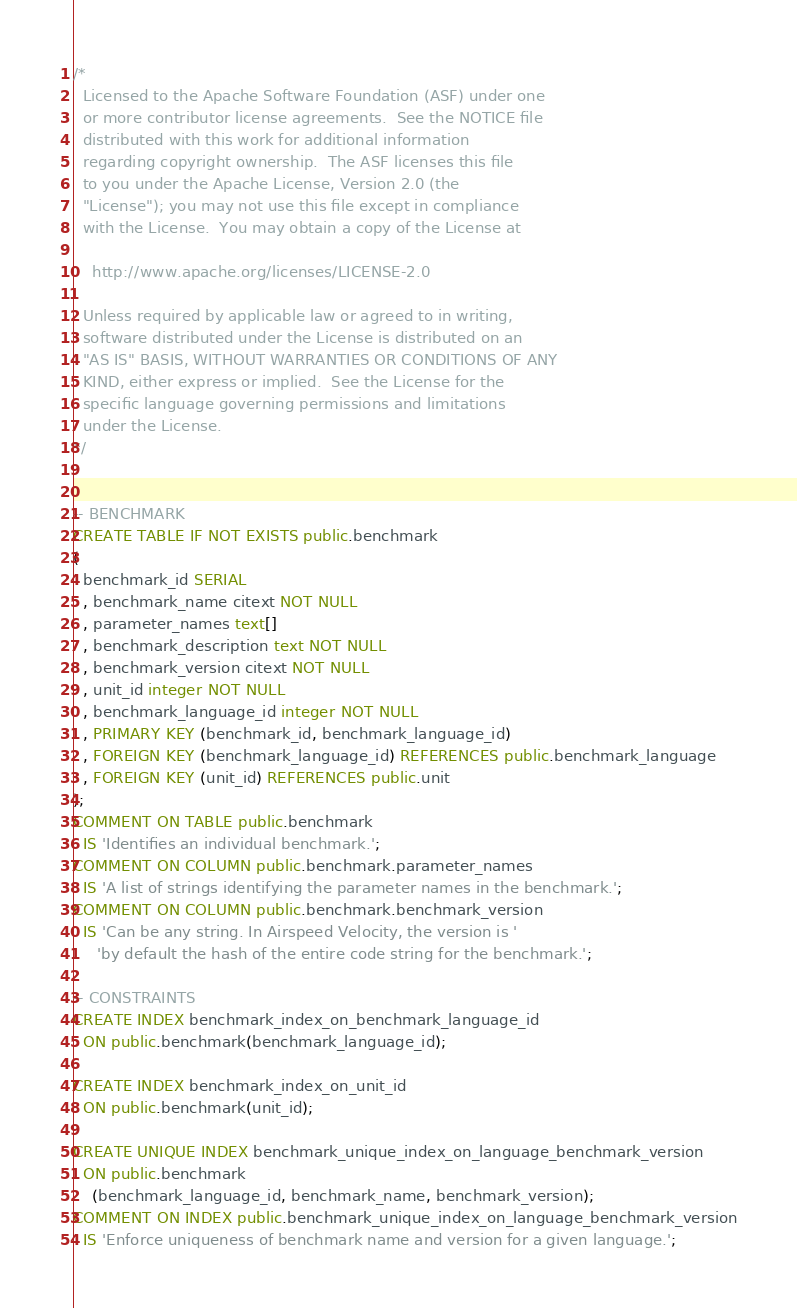<code> <loc_0><loc_0><loc_500><loc_500><_SQL_>/*
  Licensed to the Apache Software Foundation (ASF) under one
  or more contributor license agreements.  See the NOTICE file
  distributed with this work for additional information
  regarding copyright ownership.  The ASF licenses this file
  to you under the Apache License, Version 2.0 (the
  "License"); you may not use this file except in compliance
  with the License.  You may obtain a copy of the License at

    http://www.apache.org/licenses/LICENSE-2.0

  Unless required by applicable law or agreed to in writing,
  software distributed under the License is distributed on an
  "AS IS" BASIS, WITHOUT WARRANTIES OR CONDITIONS OF ANY
  KIND, either express or implied.  See the License for the
  specific language governing permissions and limitations
  under the License.
*/


-- BENCHMARK
CREATE TABLE IF NOT EXISTS public.benchmark
(
  benchmark_id SERIAL
  , benchmark_name citext NOT NULL
  , parameter_names text[]
  , benchmark_description text NOT NULL
  , benchmark_version citext NOT NULL
  , unit_id integer NOT NULL
  , benchmark_language_id integer NOT NULL
  , PRIMARY KEY (benchmark_id, benchmark_language_id)
  , FOREIGN KEY (benchmark_language_id) REFERENCES public.benchmark_language
  , FOREIGN KEY (unit_id) REFERENCES public.unit
);
COMMENT ON TABLE public.benchmark
  IS 'Identifies an individual benchmark.';
COMMENT ON COLUMN public.benchmark.parameter_names
  IS 'A list of strings identifying the parameter names in the benchmark.';
COMMENT ON COLUMN public.benchmark.benchmark_version
  IS 'Can be any string. In Airspeed Velocity, the version is '
     'by default the hash of the entire code string for the benchmark.';

-- CONSTRAINTS
CREATE INDEX benchmark_index_on_benchmark_language_id
  ON public.benchmark(benchmark_language_id);

CREATE INDEX benchmark_index_on_unit_id
  ON public.benchmark(unit_id);

CREATE UNIQUE INDEX benchmark_unique_index_on_language_benchmark_version
  ON public.benchmark
    (benchmark_language_id, benchmark_name, benchmark_version);
COMMENT ON INDEX public.benchmark_unique_index_on_language_benchmark_version
  IS 'Enforce uniqueness of benchmark name and version for a given language.';
</code> 